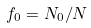<formula> <loc_0><loc_0><loc_500><loc_500>f _ { 0 } = N _ { 0 } / N</formula> 